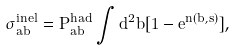Convert formula to latex. <formula><loc_0><loc_0><loc_500><loc_500>\sigma ^ { i n e l } _ { a b } = P ^ { h a d } _ { a b } \int d ^ { 2 } \vec { b } [ 1 - e ^ { n ( b , s ) } ] ,</formula> 